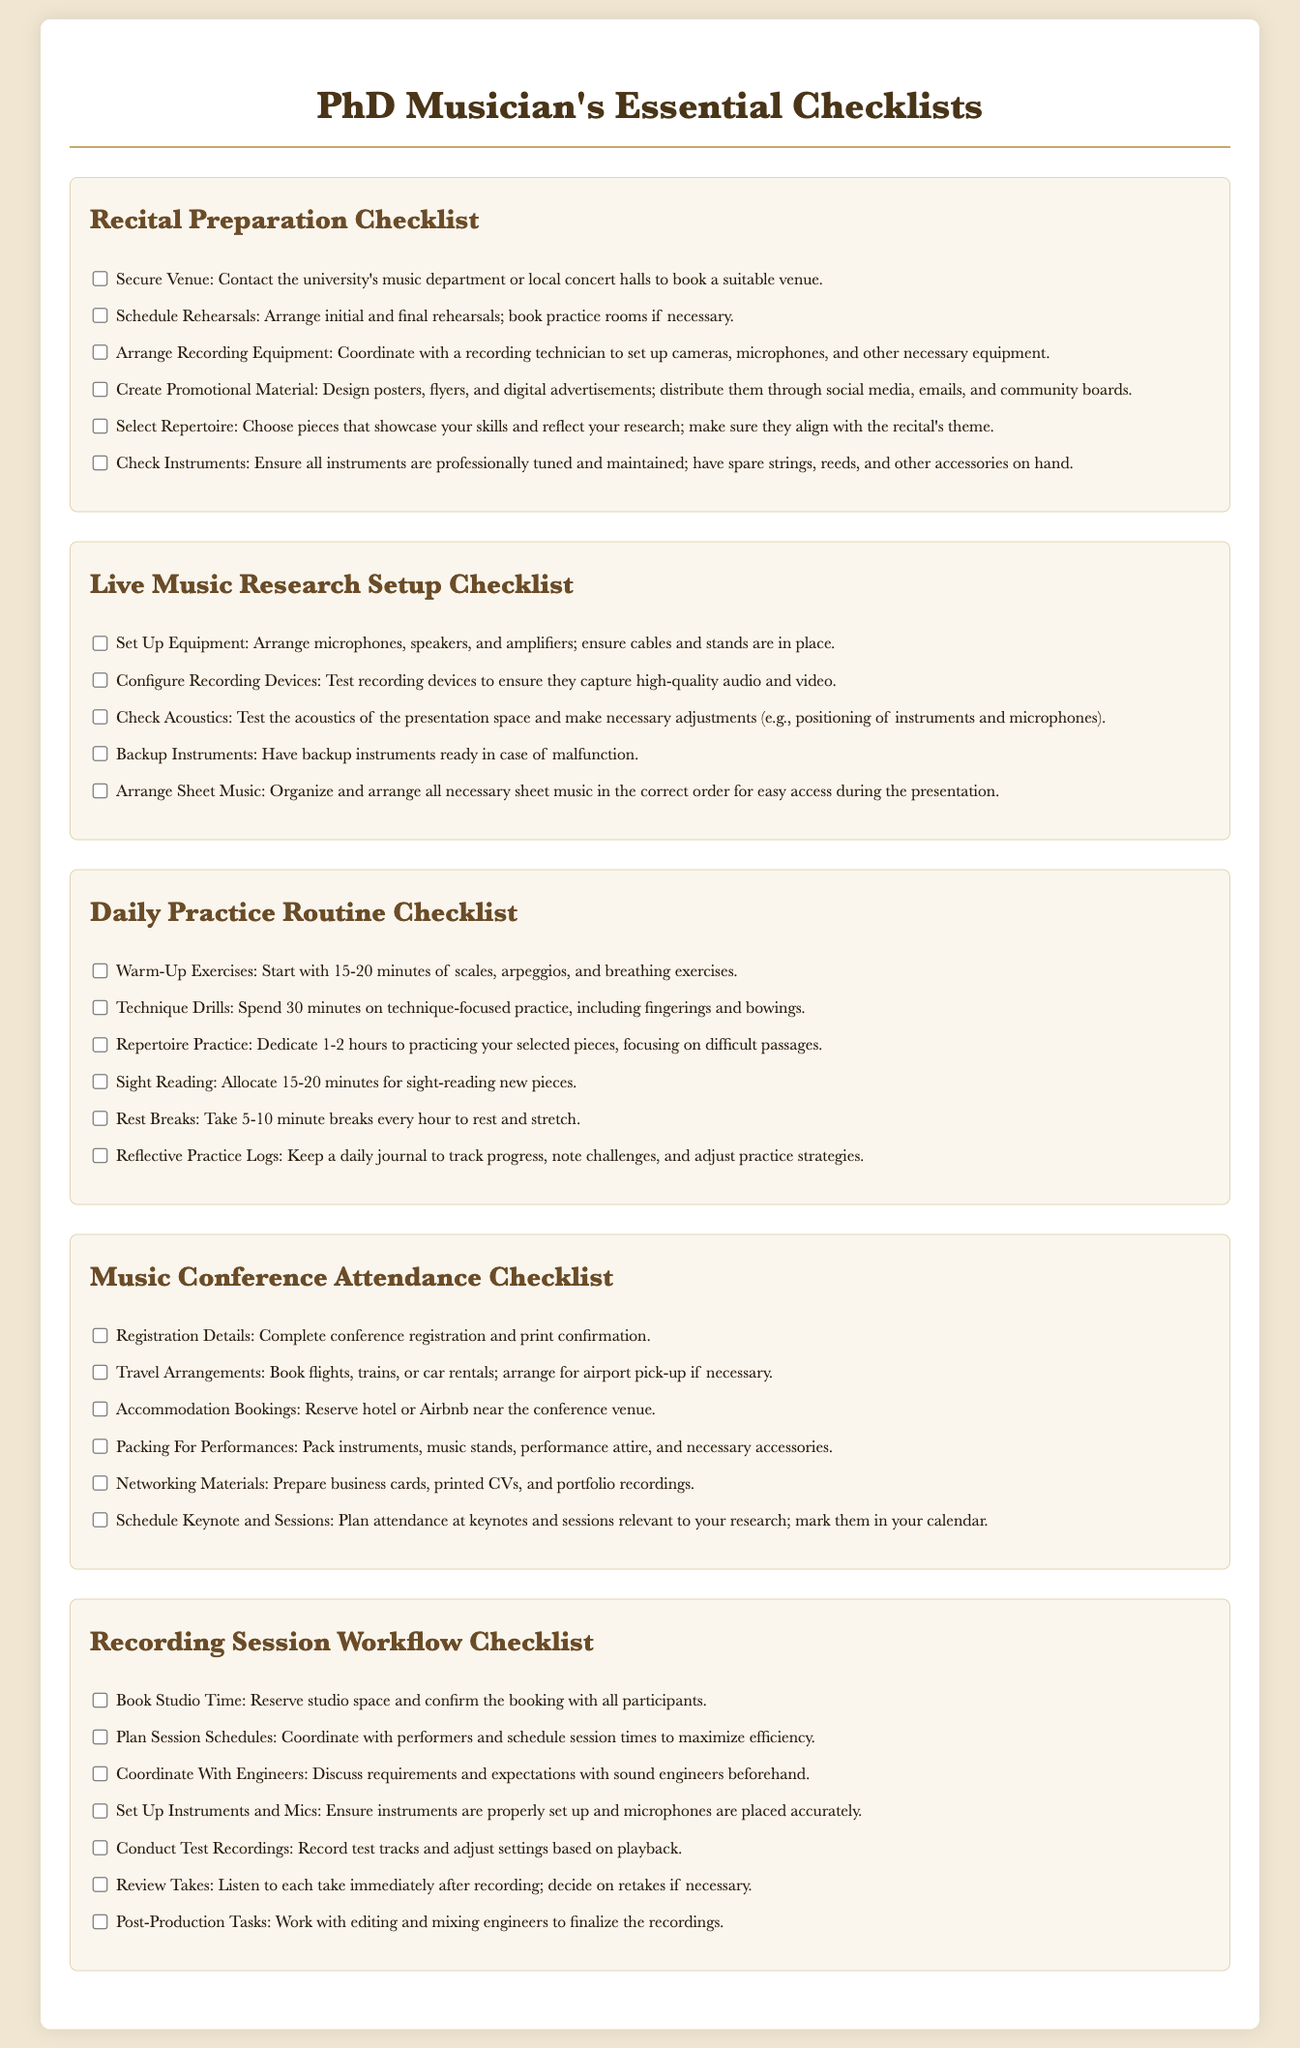what is the first item in the Recital Preparation Checklist? The first item in the checklist is securing a venue.
Answer: Secure Venue: Contact the university's music department or local concert halls to book a suitable venue how many items are listed in the Live Music Research Setup Checklist? There are five items listed in the checklist.
Answer: 5 what is the duration allocated for warm-up exercises in the Daily Practice Routine Checklist? The checklist allocates 15-20 minutes for warm-up exercises.
Answer: 15-20 minutes which checklist includes arranging sheet music? Arranging sheet music is included in the Live Music Research Setup Checklist.
Answer: Live Music Research Setup Checklist what should be packed for performances according to the Music Conference Attendance Checklist? Instruments, music stands, performance attire, and necessary accessories should be packed.
Answer: Pack instruments, music stands, performance attire, and necessary accessories how many tasks are there in the Recording Session Workflow Checklist? There are seven tasks listed in the checklist.
Answer: 7 